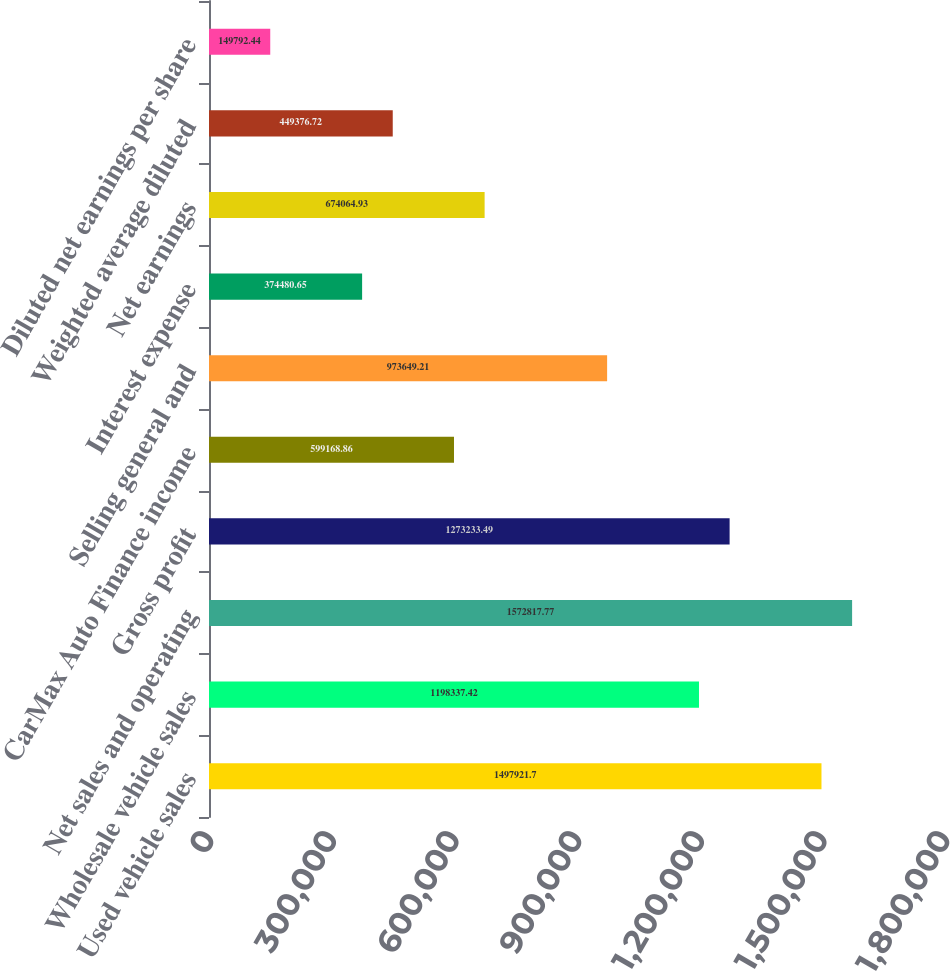Convert chart to OTSL. <chart><loc_0><loc_0><loc_500><loc_500><bar_chart><fcel>Used vehicle sales<fcel>Wholesale vehicle sales<fcel>Net sales and operating<fcel>Gross profit<fcel>CarMax Auto Finance income<fcel>Selling general and<fcel>Interest expense<fcel>Net earnings<fcel>Weighted average diluted<fcel>Diluted net earnings per share<nl><fcel>1.49792e+06<fcel>1.19834e+06<fcel>1.57282e+06<fcel>1.27323e+06<fcel>599169<fcel>973649<fcel>374481<fcel>674065<fcel>449377<fcel>149792<nl></chart> 